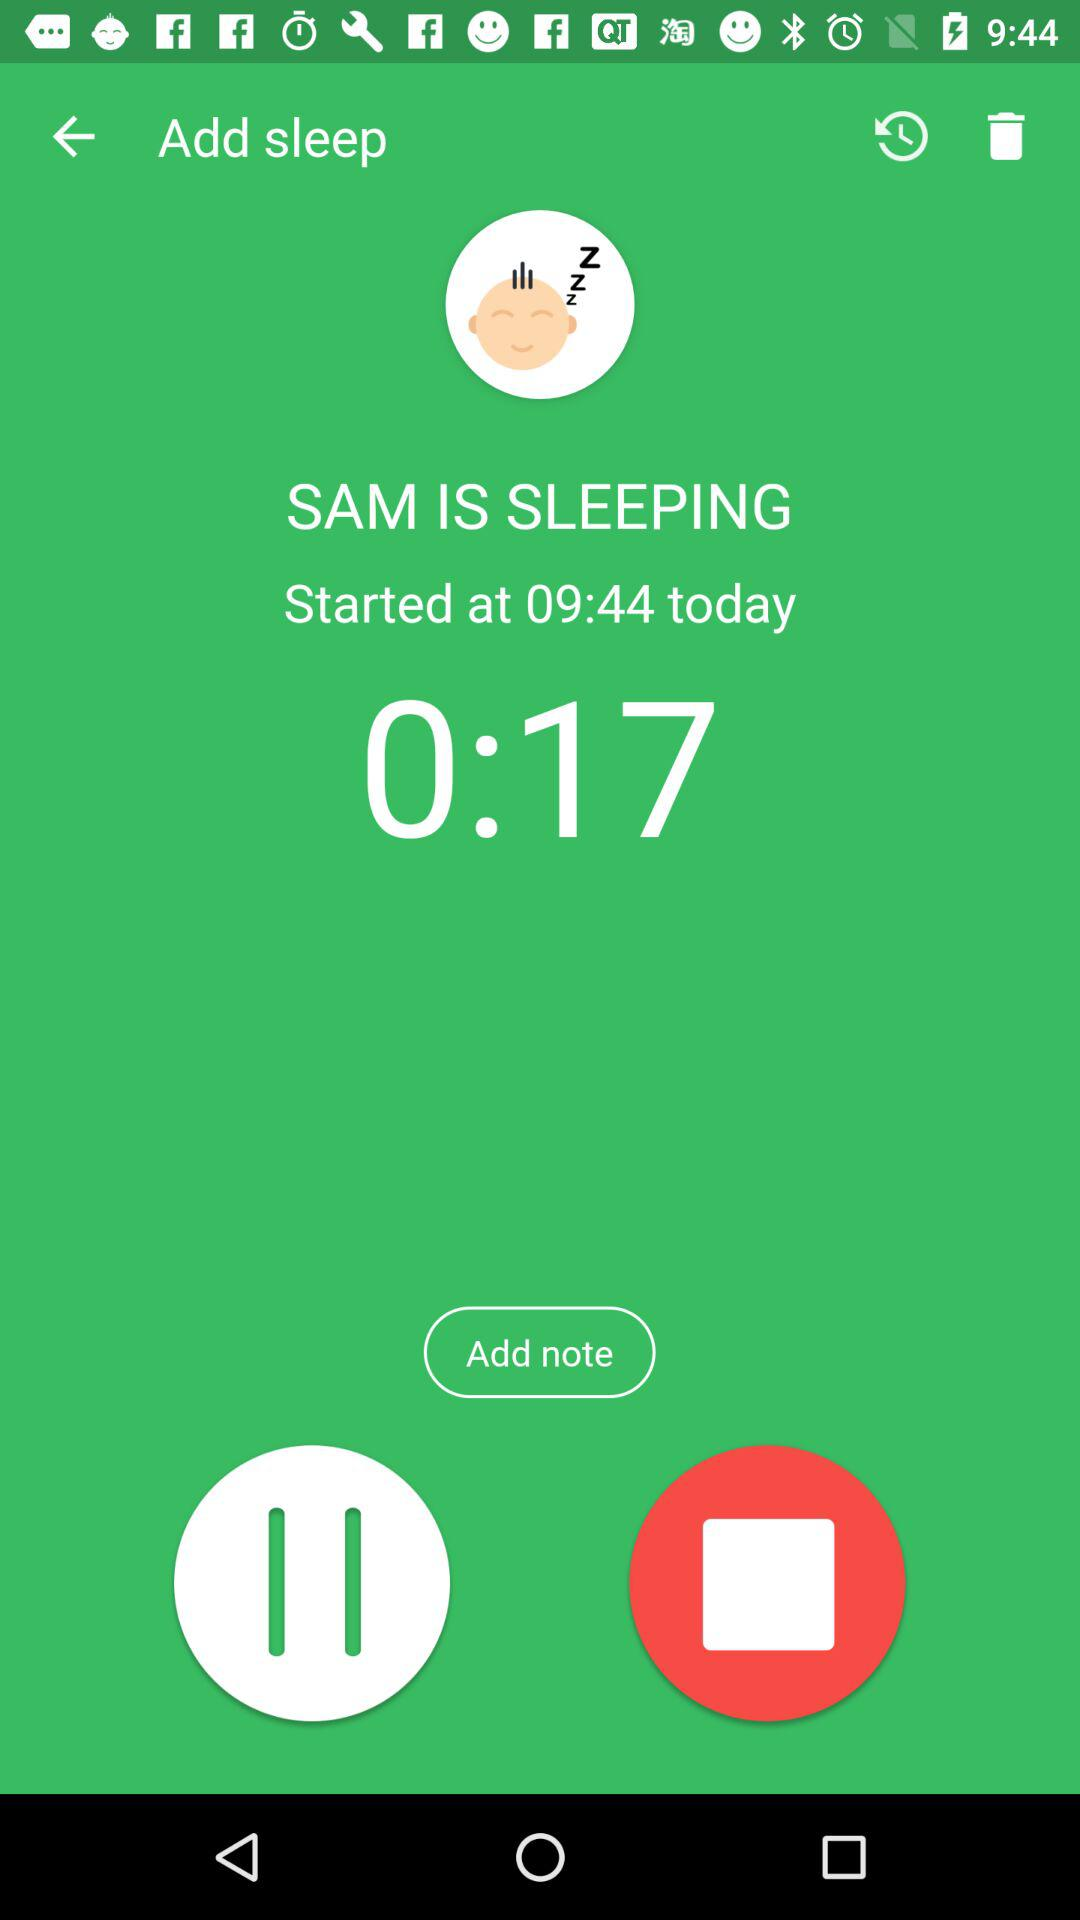How long has Sam been sleeping for?
Answer the question using a single word or phrase. 0:17 